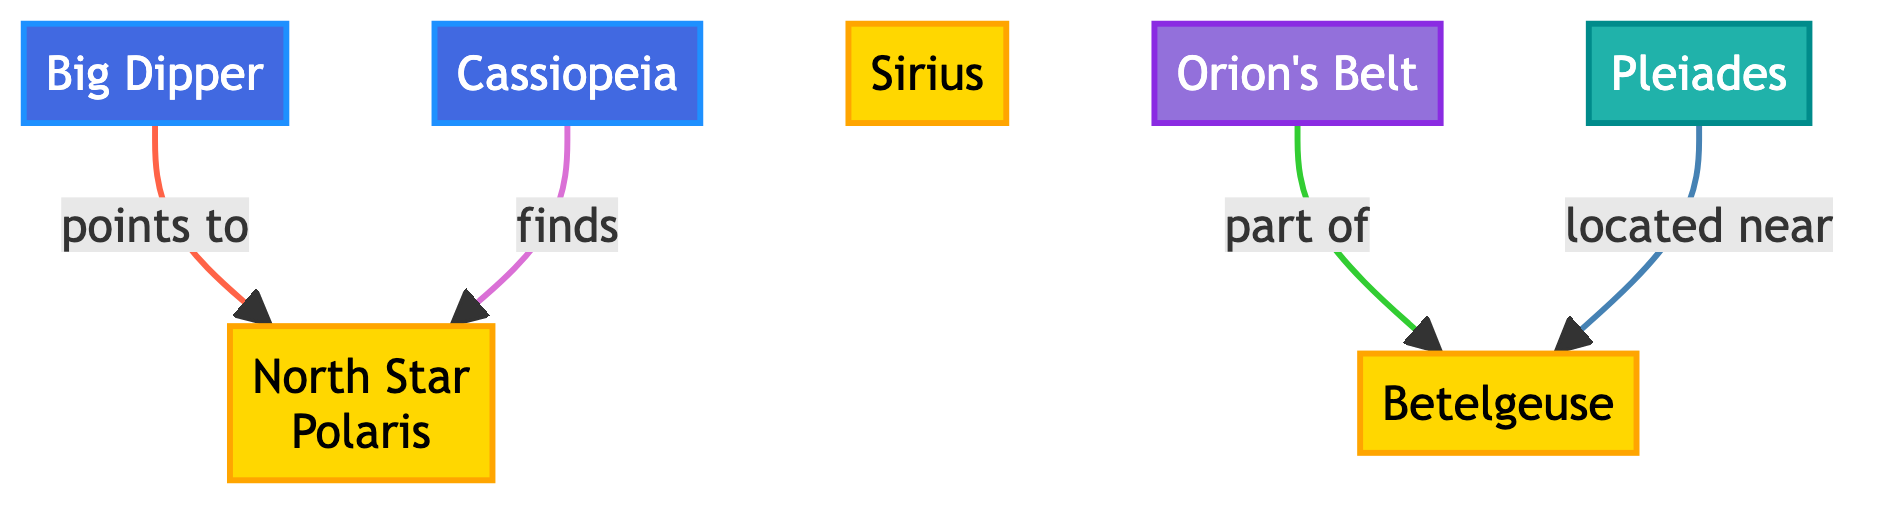What is the brightest star shown on the diagram? The diagram indicates that Sirius is labeled as a star and is known for its brightness.
Answer: Sirius How many constellations are featured in the diagram? Upon reviewing the diagram, there are two distinct constellations shown: the Big Dipper and Cassiopeia.
Answer: 2 Which star points to the North Star? The relationship shown indicates that the Big Dipper has an arrow pointing to the North Star, Polaris.
Answer: Big Dipper What asterism is part of the constellation Orion? The diagram shows that Orion's Belt is an asterism associated with the star Betelgeuse.
Answer: Betelgeuse Which star cluster is near Betelgeuse? Referring to the diagram, it shows that the Pleiades star cluster is located near Betelgeuse.
Answer: Pleiades What color represents the stars in the diagram? The stars are represented with a fill color of #FFD700, which corresponds to a gold color.
Answer: Gold How is Cassiopeia related to the North Star? The diagram illustrates that Cassiopeia has a directional relationship that indicates it can be used to find the North Star, Polaris.
Answer: Finds What is the primary color associated with the constellation nodes? The constellations are represented with a fill color of #4169E1, a shade of blue.
Answer: Blue Which star is referred to in the diagram as Orion's Belt? Orion's Belt is mentioned as an asterism in the diagram, but it does not have a specific star named after it in that form; however, it is associated with Betelgeuse.
Answer: N/A (Astermism) 